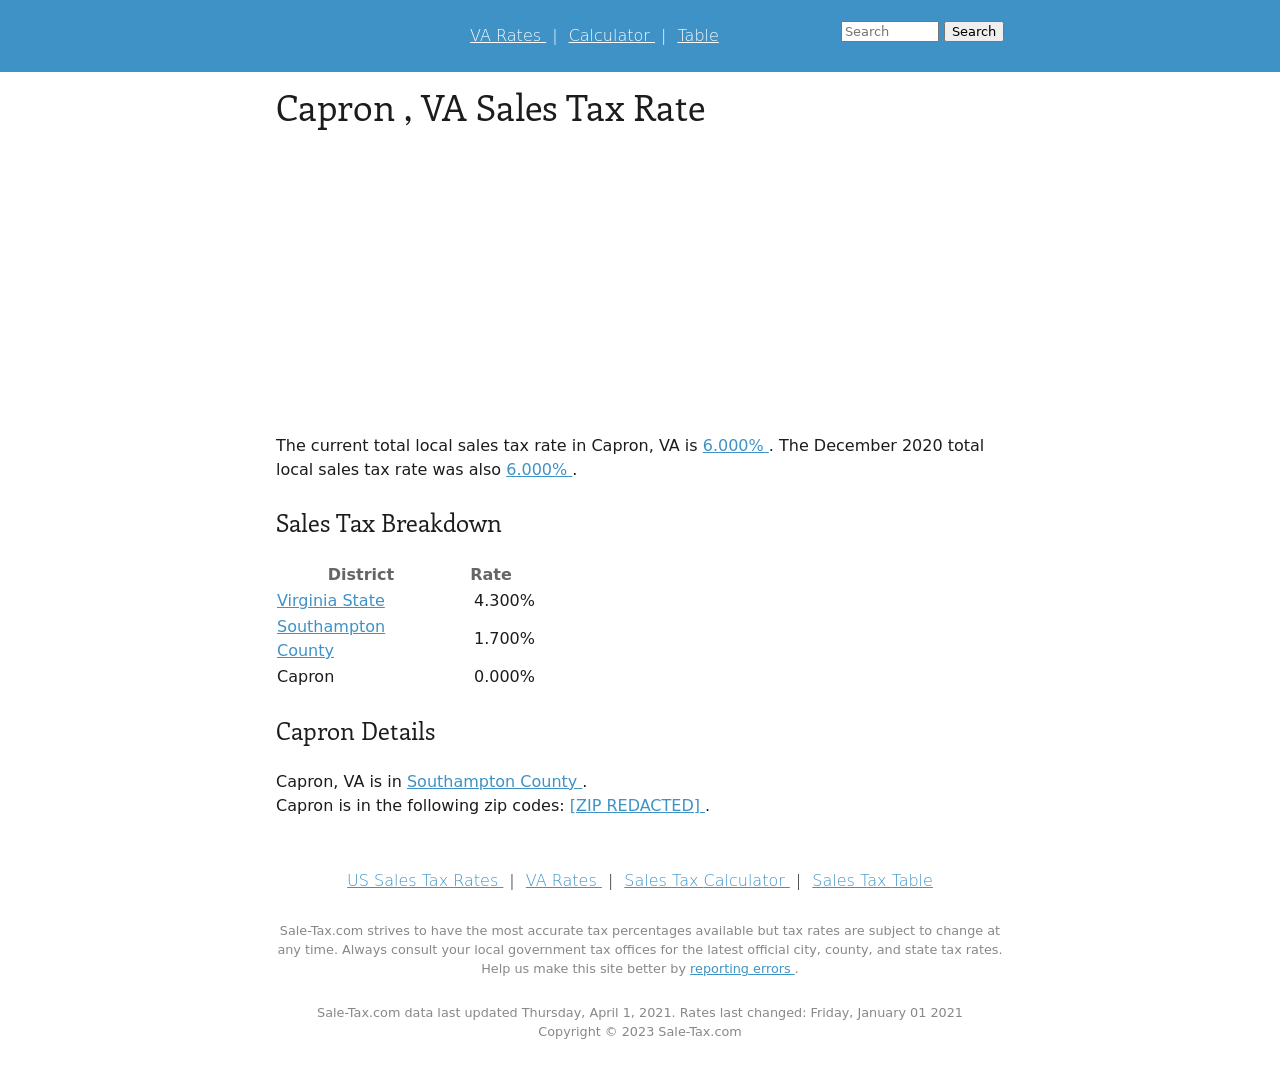What are some common services or infrastructures maintained by the sales tax collected in Capron, VA? Sales tax collected in regions like Capron, VA typically goes towards funding essential public services. These can include public schooling, transportation infrastructure, public safety like police and fire services, and maintenance of parks and recreational areas. Each level of tax, whether state, county, or local, helps fund various aspects of these services to enhance community welfare. 